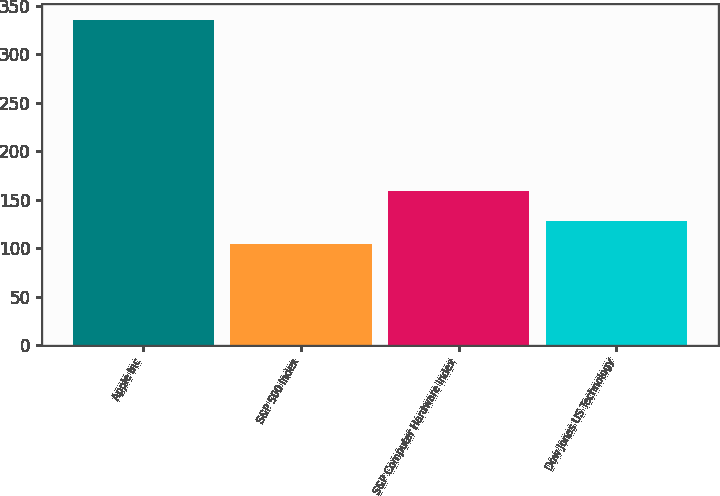Convert chart to OTSL. <chart><loc_0><loc_0><loc_500><loc_500><bar_chart><fcel>Apple Inc<fcel>S&P 500 Index<fcel>S&P Computer Hardware Index<fcel>Dow Jones US Technology<nl><fcel>335<fcel>104<fcel>159<fcel>128<nl></chart> 